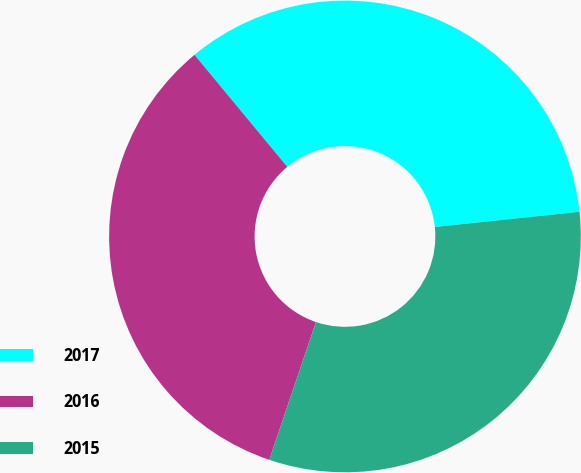<chart> <loc_0><loc_0><loc_500><loc_500><pie_chart><fcel>2017<fcel>2016<fcel>2015<nl><fcel>34.34%<fcel>33.79%<fcel>31.87%<nl></chart> 